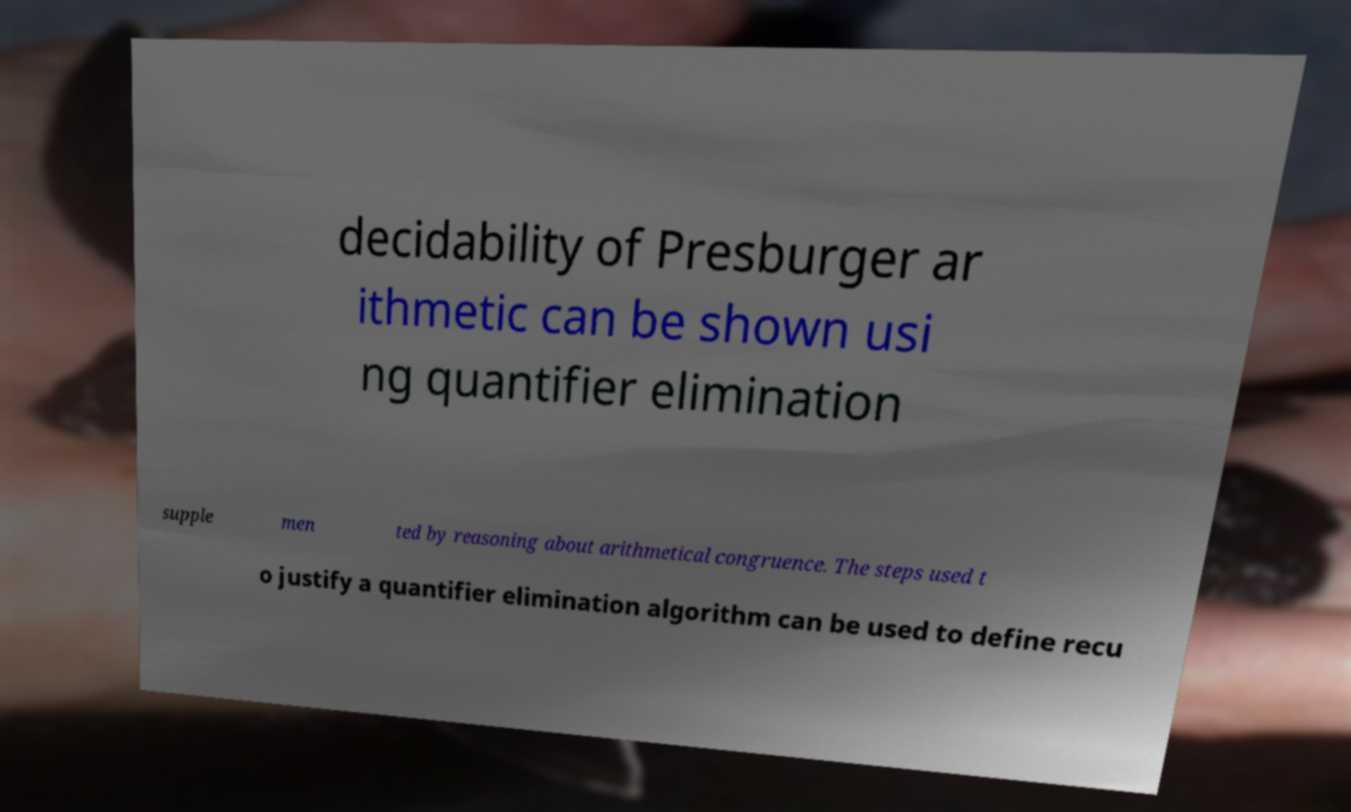Please read and relay the text visible in this image. What does it say? decidability of Presburger ar ithmetic can be shown usi ng quantifier elimination supple men ted by reasoning about arithmetical congruence. The steps used t o justify a quantifier elimination algorithm can be used to define recu 